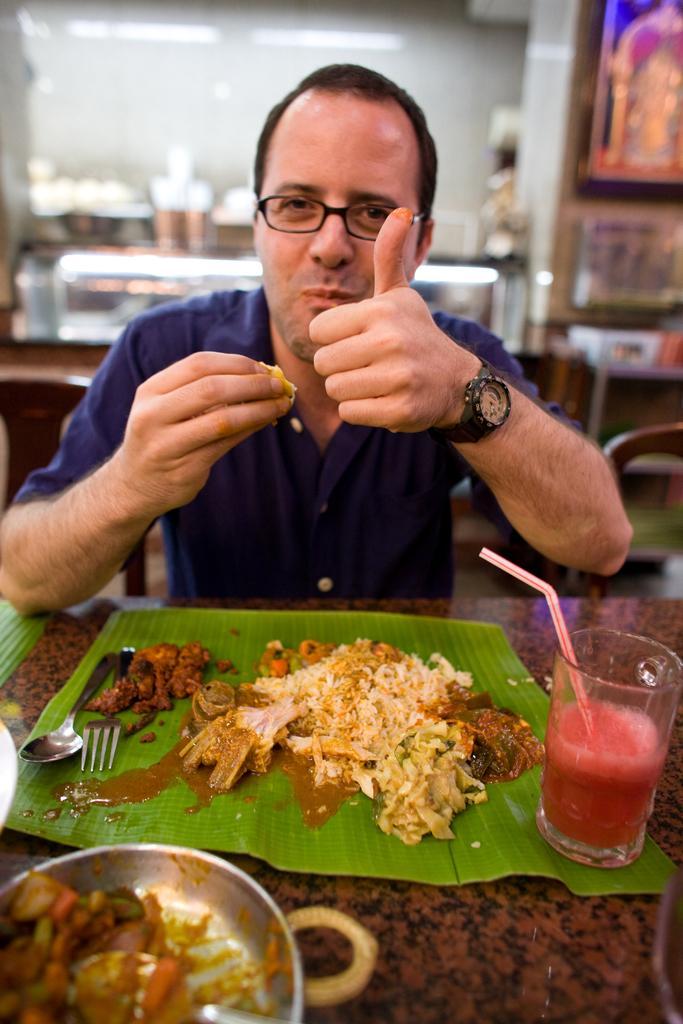Describe this image in one or two sentences. At the bottom of the image we can see a table, on the table we can see some bowls, glasses, leaf, food, spoon and fork. Behind the table a person is sitting and smiling. Behind him we can see a wall, on the wall we can see some frames and bowls. At the top of the image we can see some lights. 